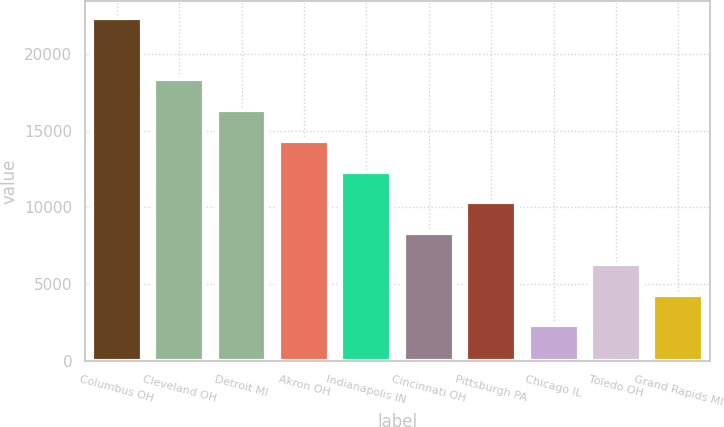Convert chart. <chart><loc_0><loc_0><loc_500><loc_500><bar_chart><fcel>Columbus OH<fcel>Cleveland OH<fcel>Detroit MI<fcel>Akron OH<fcel>Indianapolis IN<fcel>Cincinnati OH<fcel>Pittsburgh PA<fcel>Chicago IL<fcel>Toledo OH<fcel>Grand Rapids MI<nl><fcel>22332<fcel>18330.4<fcel>16329.6<fcel>14328.8<fcel>12328<fcel>8326.4<fcel>10327.2<fcel>2324<fcel>6325.6<fcel>4324.8<nl></chart> 